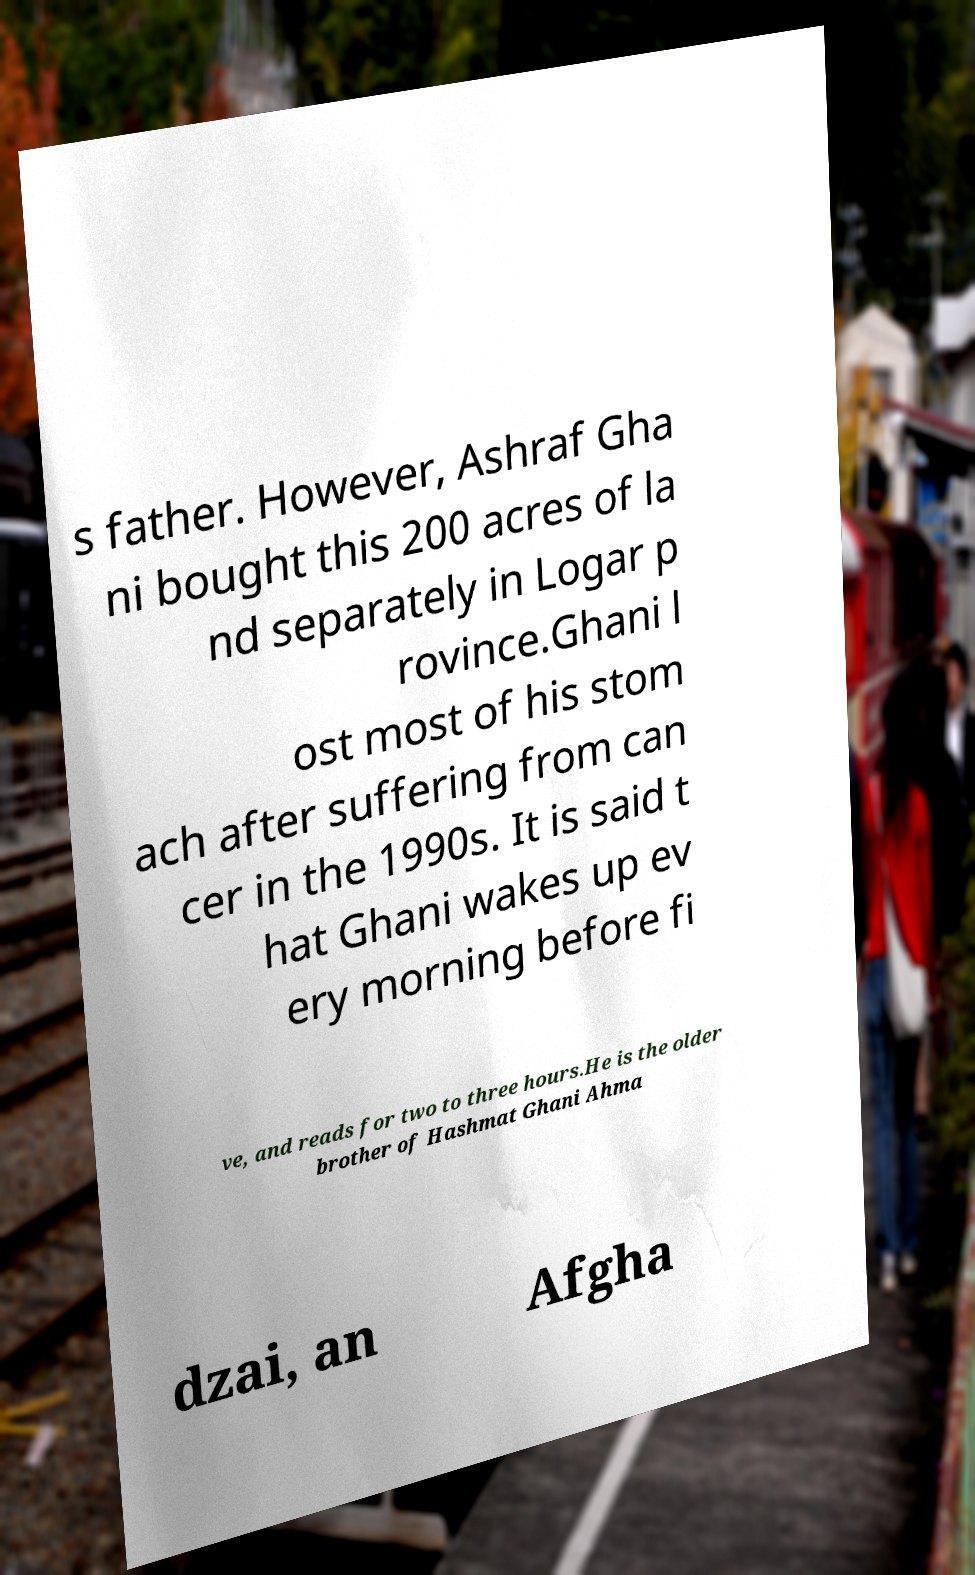Please identify and transcribe the text found in this image. s father. However, Ashraf Gha ni bought this 200 acres of la nd separately in Logar p rovince.Ghani l ost most of his stom ach after suffering from can cer in the 1990s. It is said t hat Ghani wakes up ev ery morning before fi ve, and reads for two to three hours.He is the older brother of Hashmat Ghani Ahma dzai, an Afgha 